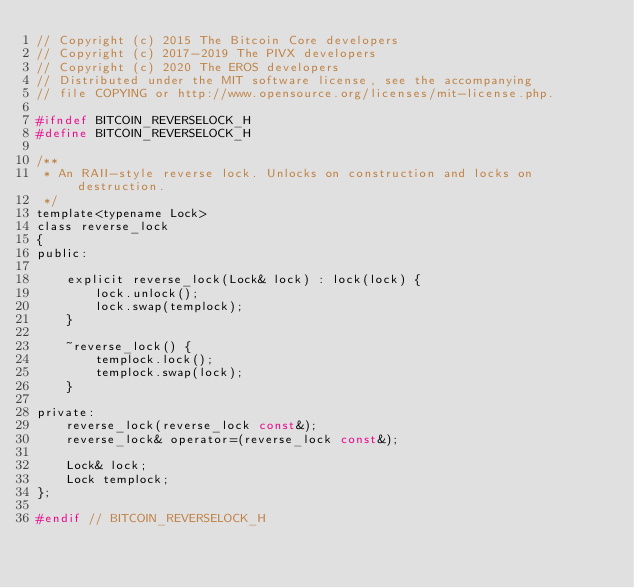Convert code to text. <code><loc_0><loc_0><loc_500><loc_500><_C_>// Copyright (c) 2015 The Bitcoin Core developers
// Copyright (c) 2017-2019 The PIVX developers
// Copyright (c) 2020 The EROS developers
// Distributed under the MIT software license, see the accompanying
// file COPYING or http://www.opensource.org/licenses/mit-license.php.

#ifndef BITCOIN_REVERSELOCK_H
#define BITCOIN_REVERSELOCK_H

/**
 * An RAII-style reverse lock. Unlocks on construction and locks on destruction.
 */
template<typename Lock>
class reverse_lock
{
public:

    explicit reverse_lock(Lock& lock) : lock(lock) {
        lock.unlock();
        lock.swap(templock);
    }

    ~reverse_lock() {
        templock.lock();
        templock.swap(lock);
    }

private:
    reverse_lock(reverse_lock const&);
    reverse_lock& operator=(reverse_lock const&);

    Lock& lock;
    Lock templock;
};

#endif // BITCOIN_REVERSELOCK_H
</code> 